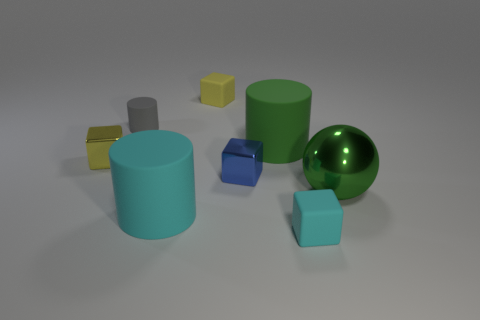What is the size of the green thing left of the metallic ball? The green object to the left of the shiny metallic ball appears to be a mid-sized cylinder, visually smaller than the cylindrical objects to its right but larger than the small geometric shapes further to its left. 